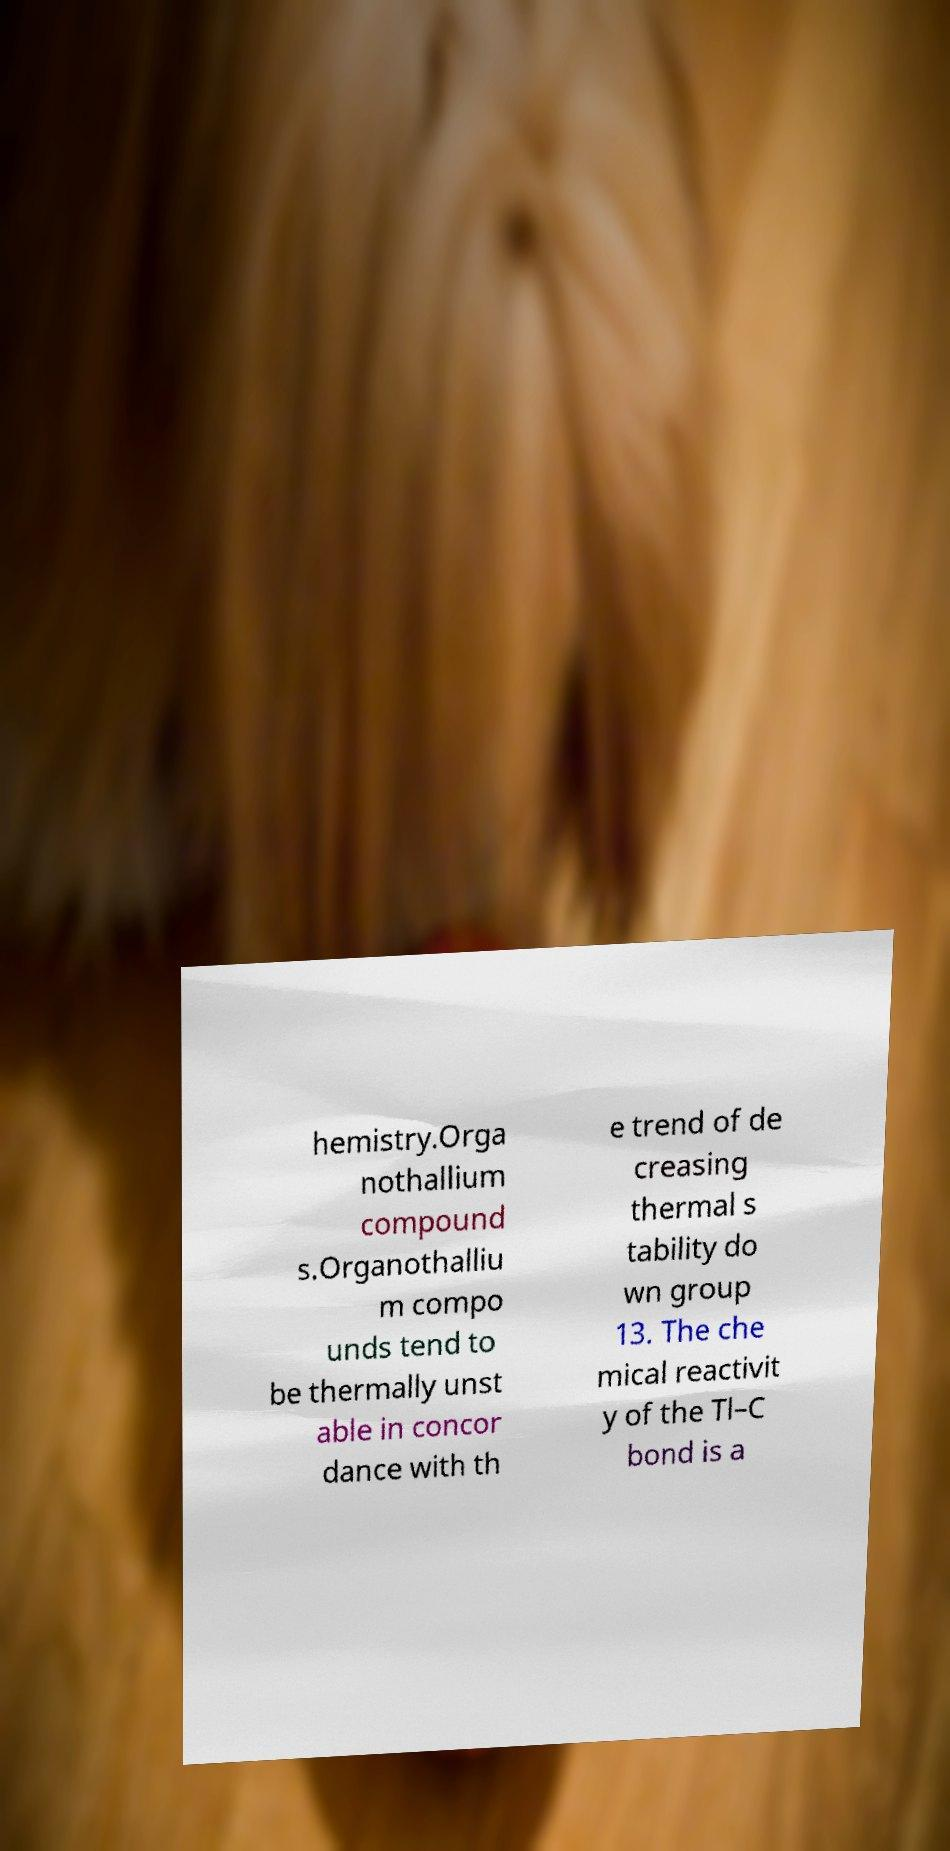Could you extract and type out the text from this image? hemistry.Orga nothallium compound s.Organothalliu m compo unds tend to be thermally unst able in concor dance with th e trend of de creasing thermal s tability do wn group 13. The che mical reactivit y of the Tl–C bond is a 